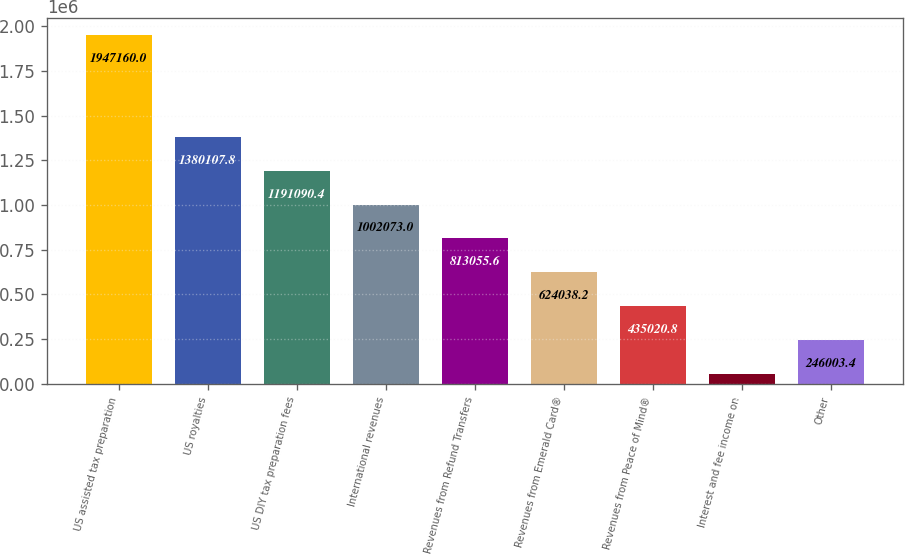<chart> <loc_0><loc_0><loc_500><loc_500><bar_chart><fcel>US assisted tax preparation<fcel>US royalties<fcel>US DIY tax preparation fees<fcel>International revenues<fcel>Revenues from Refund Transfers<fcel>Revenues from Emerald Card®<fcel>Revenues from Peace of Mind®<fcel>Interest and fee income on<fcel>Other<nl><fcel>1.94716e+06<fcel>1.38011e+06<fcel>1.19109e+06<fcel>1.00207e+06<fcel>813056<fcel>624038<fcel>435021<fcel>56986<fcel>246003<nl></chart> 